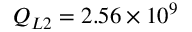Convert formula to latex. <formula><loc_0><loc_0><loc_500><loc_500>Q _ { L 2 } = 2 . 5 6 \times 1 0 ^ { 9 }</formula> 